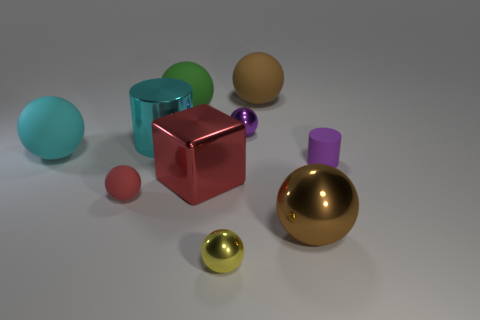Subtract 3 balls. How many balls are left? 4 Subtract all small purple shiny spheres. How many spheres are left? 6 Subtract all yellow balls. How many balls are left? 6 Subtract all gray spheres. Subtract all red cubes. How many spheres are left? 7 Subtract all blocks. How many objects are left? 9 Add 1 large balls. How many large balls exist? 5 Subtract 1 red balls. How many objects are left? 9 Subtract all brown metal objects. Subtract all big matte cylinders. How many objects are left? 9 Add 9 tiny purple metallic balls. How many tiny purple metallic balls are left? 10 